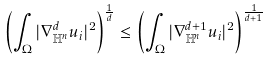Convert formula to latex. <formula><loc_0><loc_0><loc_500><loc_500>\left ( \int _ { \Omega } | \nabla _ { \mathbb { H } ^ { n } } ^ { d } u _ { i } | ^ { 2 } \right ) ^ { \frac { 1 } { d } } \leq \left ( \int _ { \Omega } | \nabla _ { \mathbb { H } ^ { n } } ^ { d + 1 } u _ { i } | ^ { 2 } \right ) ^ { \frac { 1 } { d + 1 } }</formula> 